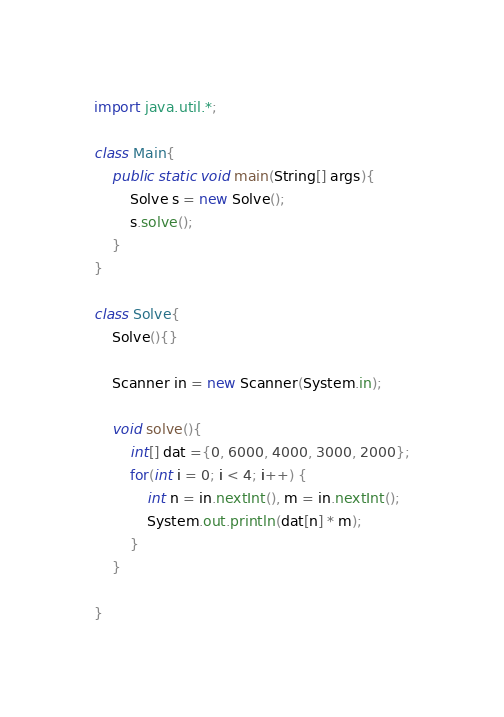Convert code to text. <code><loc_0><loc_0><loc_500><loc_500><_Java_>import java.util.*;

class Main{
	public static void main(String[] args){
		Solve s = new Solve();
		s.solve();
	}	
}

class Solve{
	Solve(){}
	
	Scanner in = new Scanner(System.in);

	void solve(){
		int[] dat ={0, 6000, 4000, 3000, 2000};
		for(int i = 0; i < 4; i++) {
			int n = in.nextInt(), m = in.nextInt();
			System.out.println(dat[n] * m);
		}
	}

}</code> 